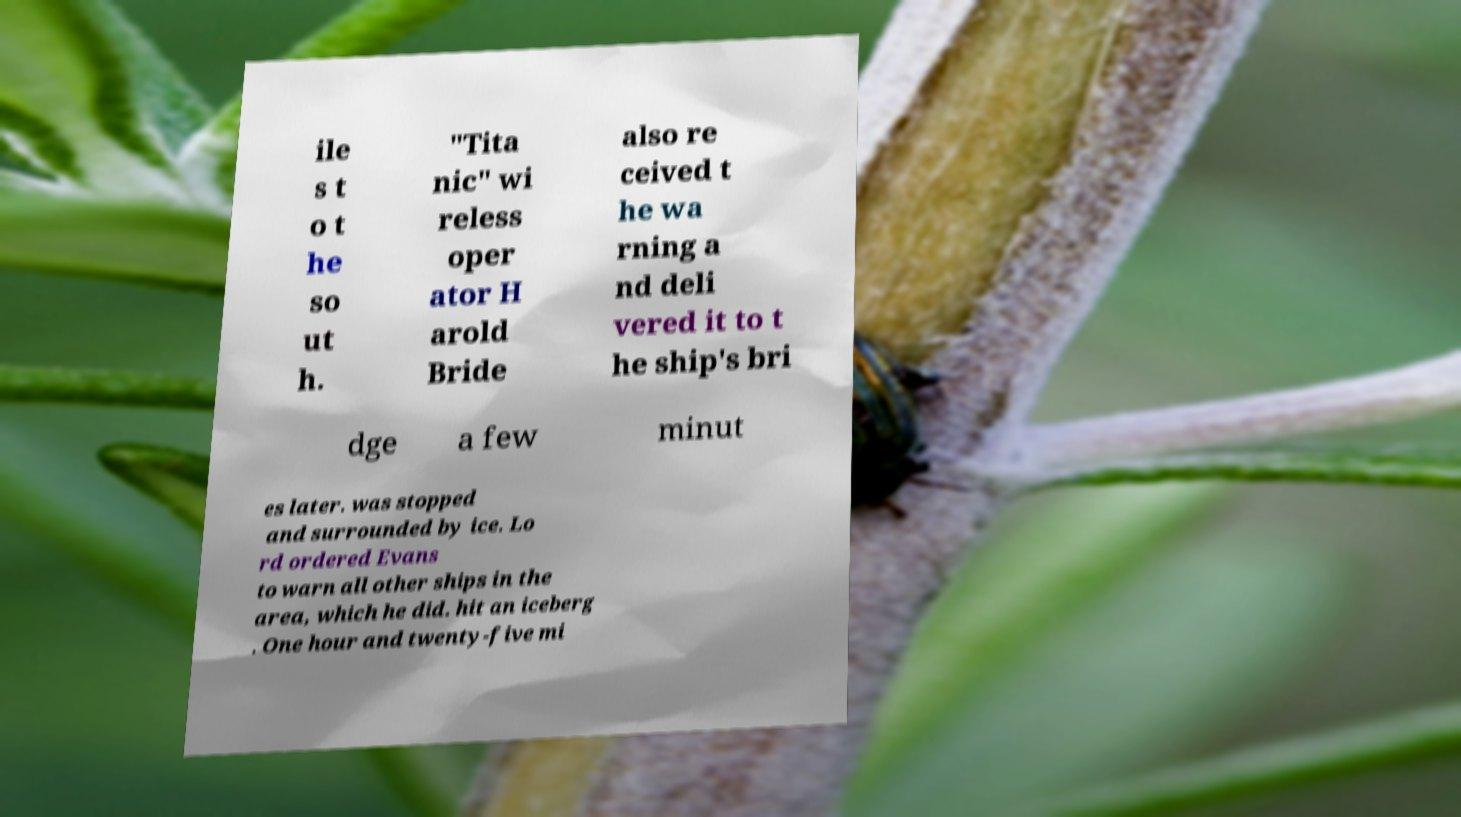What messages or text are displayed in this image? I need them in a readable, typed format. ile s t o t he so ut h. "Tita nic" wi reless oper ator H arold Bride also re ceived t he wa rning a nd deli vered it to t he ship's bri dge a few minut es later. was stopped and surrounded by ice. Lo rd ordered Evans to warn all other ships in the area, which he did. hit an iceberg . One hour and twenty-five mi 